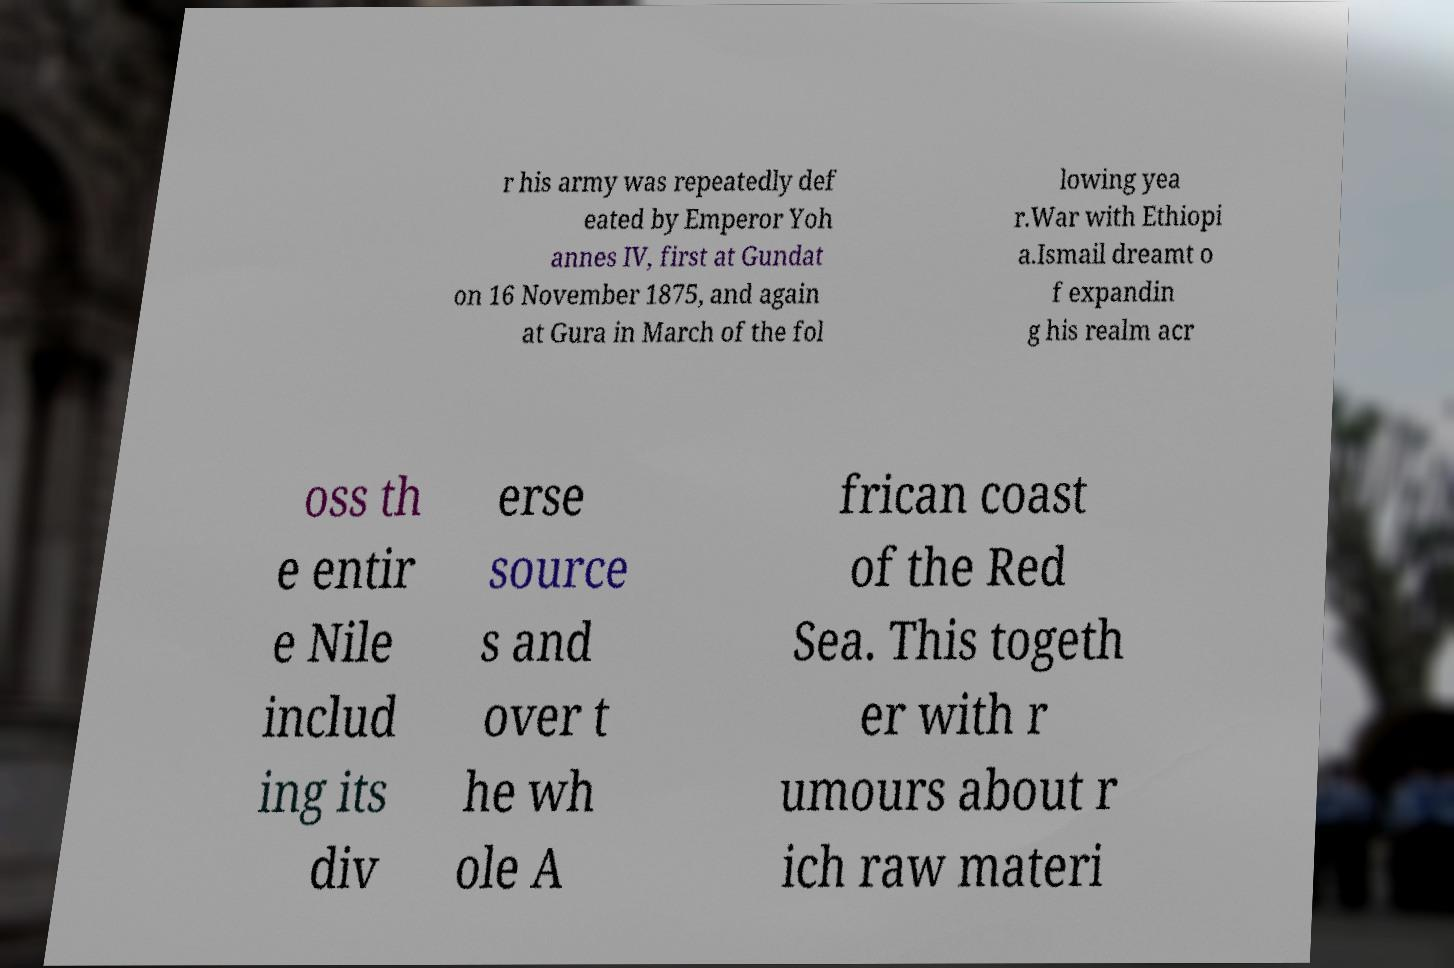Please read and relay the text visible in this image. What does it say? r his army was repeatedly def eated by Emperor Yoh annes IV, first at Gundat on 16 November 1875, and again at Gura in March of the fol lowing yea r.War with Ethiopi a.Ismail dreamt o f expandin g his realm acr oss th e entir e Nile includ ing its div erse source s and over t he wh ole A frican coast of the Red Sea. This togeth er with r umours about r ich raw materi 